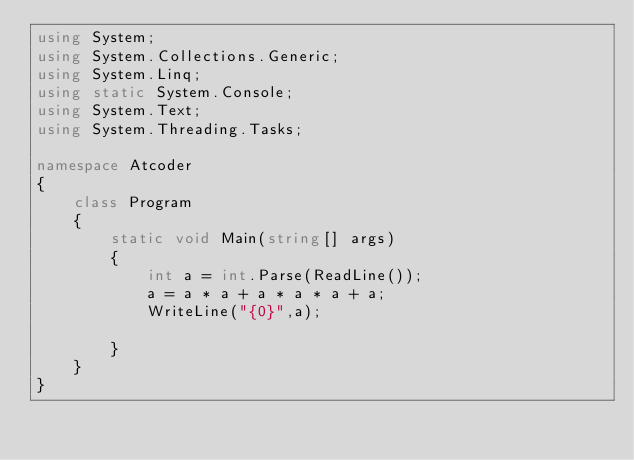<code> <loc_0><loc_0><loc_500><loc_500><_C#_>using System;
using System.Collections.Generic;
using System.Linq;
using static System.Console;
using System.Text;
using System.Threading.Tasks;

namespace Atcoder
{
    class Program
    {
        static void Main(string[] args)
        {
            int a = int.Parse(ReadLine());
            a = a * a + a * a * a + a;
            WriteLine("{0}",a);
          
        }
    }
}</code> 